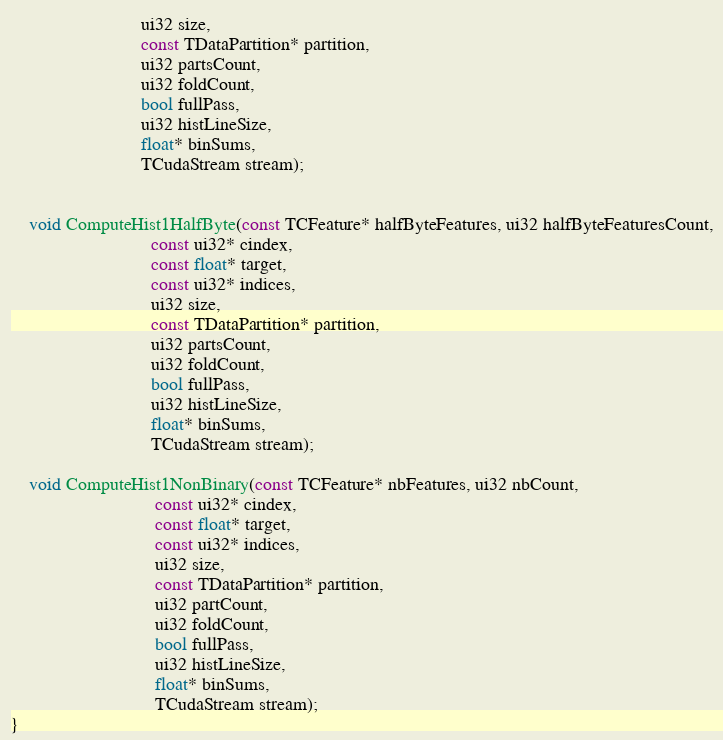<code> <loc_0><loc_0><loc_500><loc_500><_Cuda_>                            ui32 size,
                            const TDataPartition* partition,
                            ui32 partsCount,
                            ui32 foldCount,
                            bool fullPass,
                            ui32 histLineSize,
                            float* binSums,
                            TCudaStream stream);


    void ComputeHist1HalfByte(const TCFeature* halfByteFeatures, ui32 halfByteFeaturesCount,
                              const ui32* cindex,
                              const float* target,
                              const ui32* indices,
                              ui32 size,
                              const TDataPartition* partition,
                              ui32 partsCount,
                              ui32 foldCount,
                              bool fullPass,
                              ui32 histLineSize,
                              float* binSums,
                              TCudaStream stream);

    void ComputeHist1NonBinary(const TCFeature* nbFeatures, ui32 nbCount,
                               const ui32* cindex,
                               const float* target,
                               const ui32* indices,
                               ui32 size,
                               const TDataPartition* partition,
                               ui32 partCount,
                               ui32 foldCount,
                               bool fullPass,
                               ui32 histLineSize,
                               float* binSums,
                               TCudaStream stream);
}
</code> 